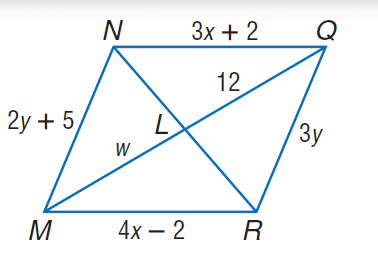Answer the mathemtical geometry problem and directly provide the correct option letter.
Question: Use parallelogram N Q R M to find N Q.
Choices: A: 13 B: 14 C: 15 D: 16 B 